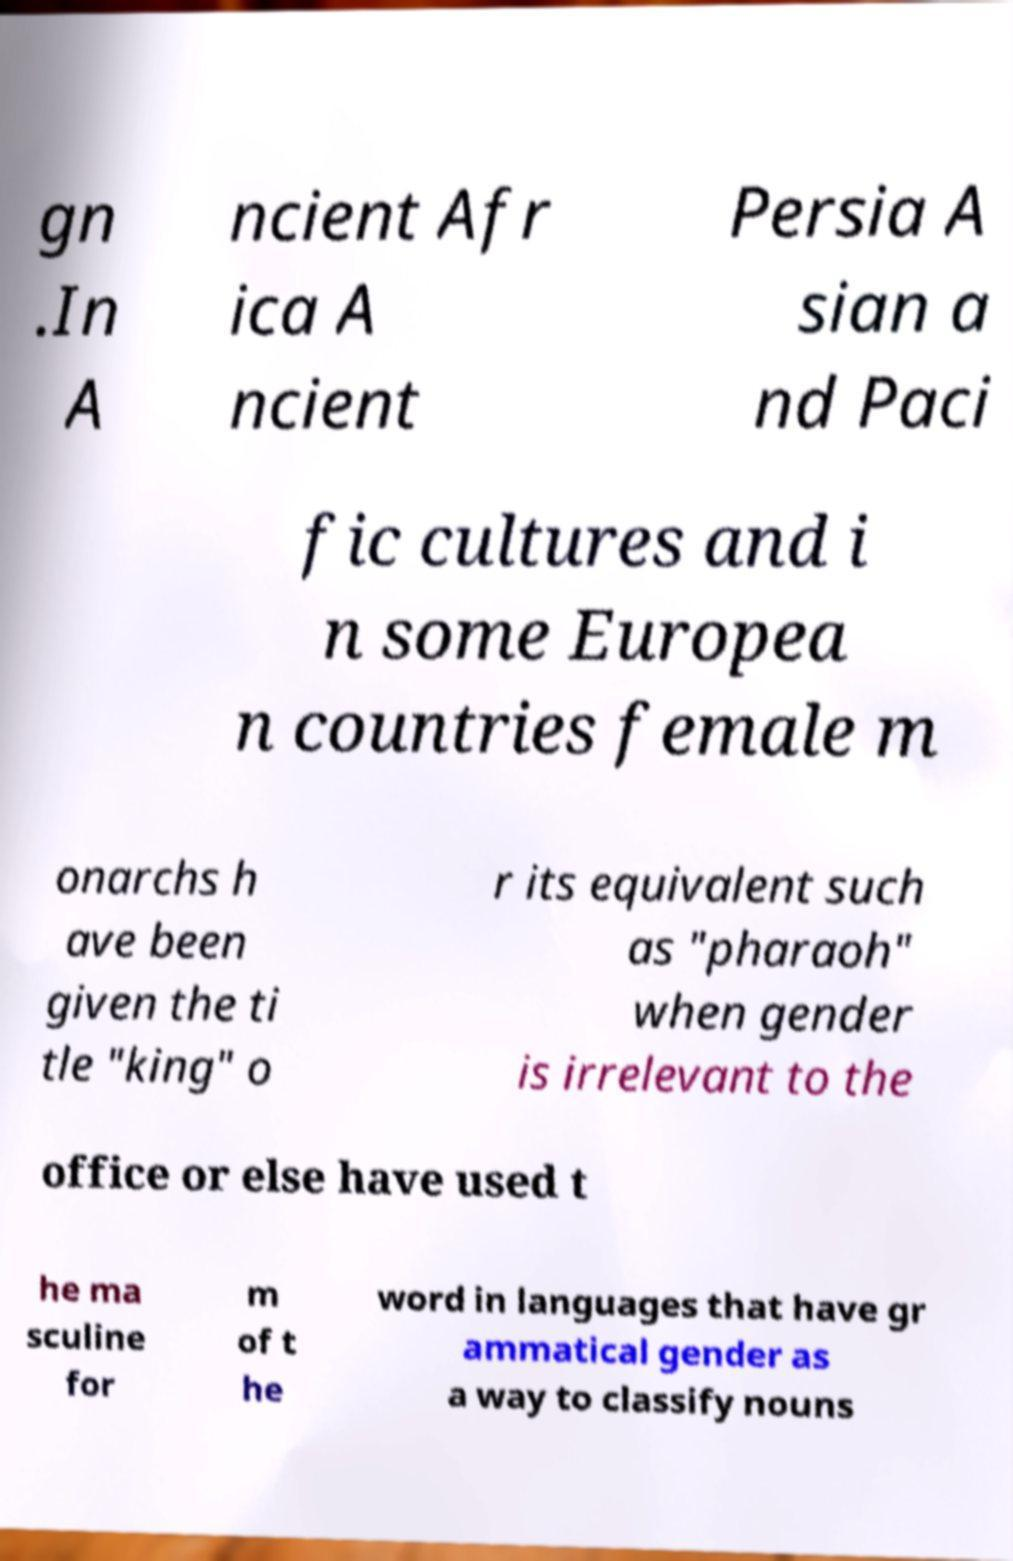Please read and relay the text visible in this image. What does it say? gn .In A ncient Afr ica A ncient Persia A sian a nd Paci fic cultures and i n some Europea n countries female m onarchs h ave been given the ti tle "king" o r its equivalent such as "pharaoh" when gender is irrelevant to the office or else have used t he ma sculine for m of t he word in languages that have gr ammatical gender as a way to classify nouns 